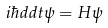Convert formula to latex. <formula><loc_0><loc_0><loc_500><loc_500>i \hbar { } { d } { d t } \psi = H \psi</formula> 